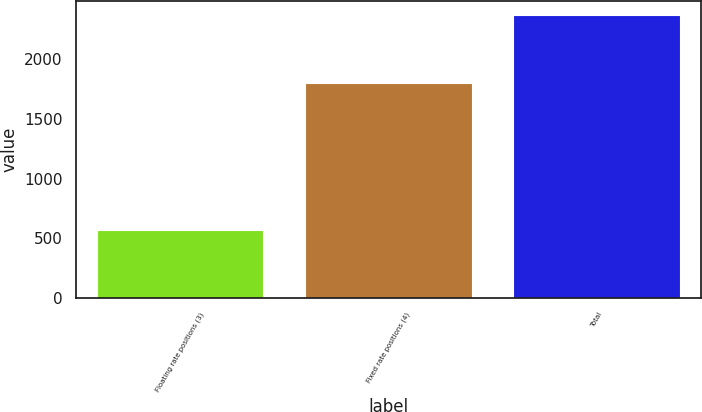Convert chart to OTSL. <chart><loc_0><loc_0><loc_500><loc_500><bar_chart><fcel>Floating rate positions (3)<fcel>Fixed rate positions (4)<fcel>Total<nl><fcel>570<fcel>1798<fcel>2368<nl></chart> 